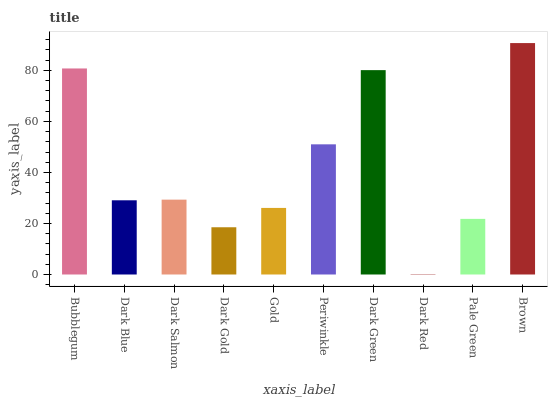Is Dark Red the minimum?
Answer yes or no. Yes. Is Brown the maximum?
Answer yes or no. Yes. Is Dark Blue the minimum?
Answer yes or no. No. Is Dark Blue the maximum?
Answer yes or no. No. Is Bubblegum greater than Dark Blue?
Answer yes or no. Yes. Is Dark Blue less than Bubblegum?
Answer yes or no. Yes. Is Dark Blue greater than Bubblegum?
Answer yes or no. No. Is Bubblegum less than Dark Blue?
Answer yes or no. No. Is Dark Salmon the high median?
Answer yes or no. Yes. Is Dark Blue the low median?
Answer yes or no. Yes. Is Dark Green the high median?
Answer yes or no. No. Is Dark Gold the low median?
Answer yes or no. No. 